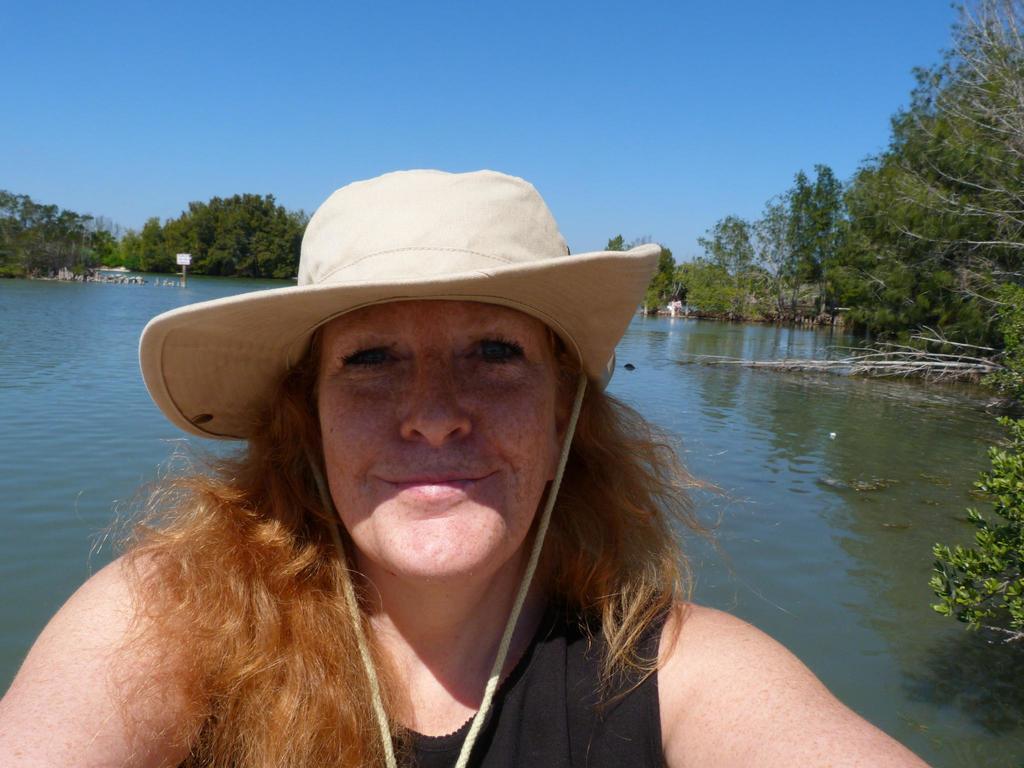Could you give a brief overview of what you see in this image? In this picture I can see at the bottom there is a woman, she is wearing a hat. In the background there is water and there are trees, at the top there is the sky. 